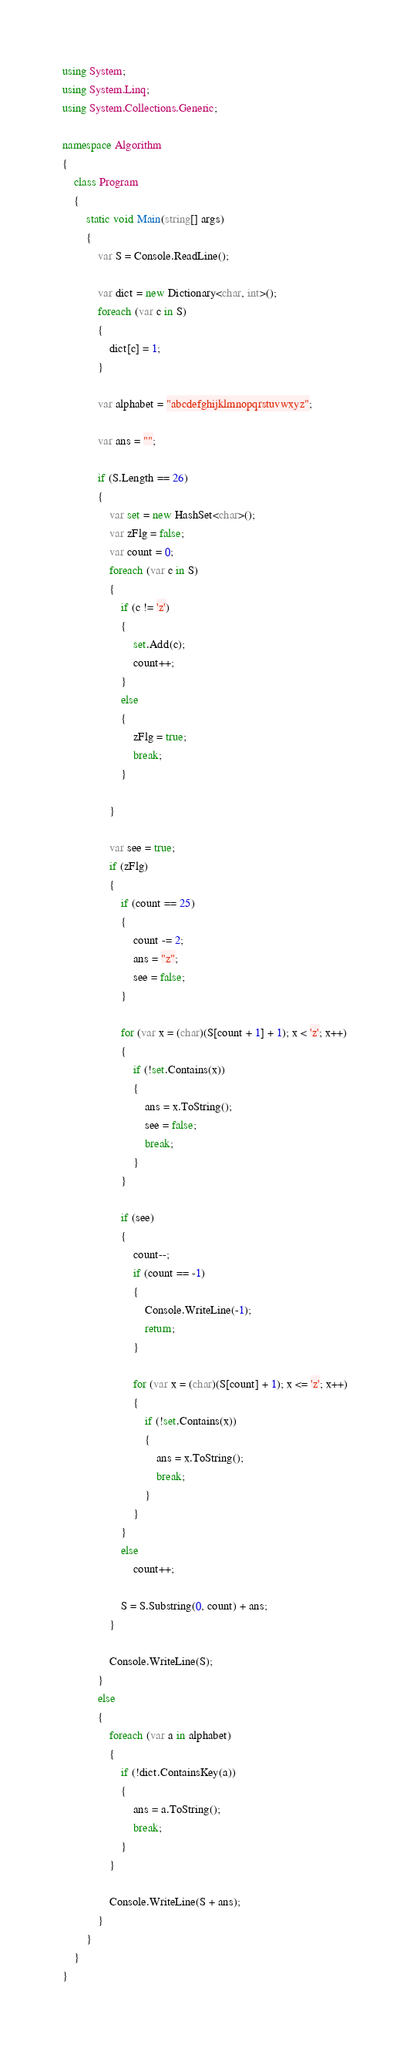Convert code to text. <code><loc_0><loc_0><loc_500><loc_500><_C#_>using System;
using System.Linq;
using System.Collections.Generic;

namespace Algorithm
{
    class Program
    {
        static void Main(string[] args)
        {
            var S = Console.ReadLine();

            var dict = new Dictionary<char, int>();
            foreach (var c in S)
            {
                dict[c] = 1;
            }

            var alphabet = "abcdefghijklmnopqrstuvwxyz";

            var ans = "";

            if (S.Length == 26)
            {
                var set = new HashSet<char>();
                var zFlg = false;
                var count = 0;
                foreach (var c in S)
                {
                    if (c != 'z')
                    {
                        set.Add(c);
                        count++;
                    }
                    else
                    {
                        zFlg = true;
                        break;
                    }

                }

                var see = true;
                if (zFlg)
                {
                    if (count == 25)
                    {
                        count -= 2;
                        ans = "z";
                        see = false;
                    }

                    for (var x = (char)(S[count + 1] + 1); x < 'z'; x++)
                    {
                        if (!set.Contains(x))
                        {
                            ans = x.ToString();
                            see = false;
                            break;
                        }
                    }

                    if (see)
                    {
                        count--;
                        if (count == -1)
                        {
                            Console.WriteLine(-1);
                            return;
                        }

                        for (var x = (char)(S[count] + 1); x <= 'z'; x++)
                        {
                            if (!set.Contains(x))
                            {
                                ans = x.ToString();
                                break;
                            }
                        }
                    }
                    else
                        count++;

                    S = S.Substring(0, count) + ans;
                }

                Console.WriteLine(S);
            }
            else
            {
                foreach (var a in alphabet)
                {
                    if (!dict.ContainsKey(a))
                    {
                        ans = a.ToString();
                        break;
                    }
                }

                Console.WriteLine(S + ans);
            }
        }
    }
}
</code> 